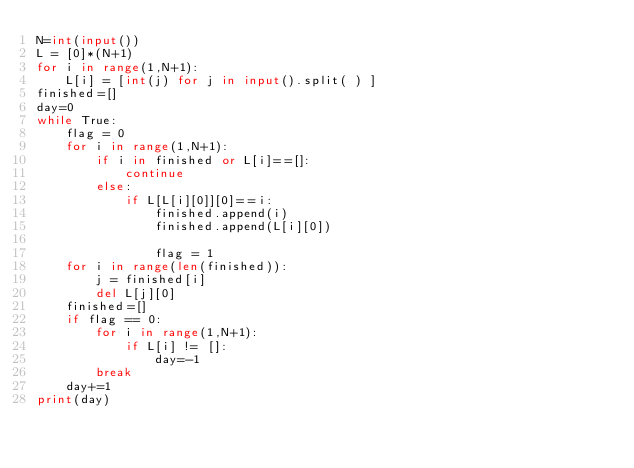<code> <loc_0><loc_0><loc_500><loc_500><_Python_>N=int(input())
L = [0]*(N+1)
for i in range(1,N+1):
    L[i] = [int(j) for j in input().split( ) ]
finished=[]
day=0
while True:
    flag = 0
    for i in range(1,N+1):
        if i in finished or L[i]==[]:
            continue
        else: 
            if L[L[i][0]][0]==i:
                finished.append(i)
                finished.append(L[i][0])
                
                flag = 1
    for i in range(len(finished)):
        j = finished[i]
        del L[j][0]
    finished=[]
    if flag == 0:
        for i in range(1,N+1):
            if L[i] != []:
                day=-1
        break
    day+=1
print(day)</code> 